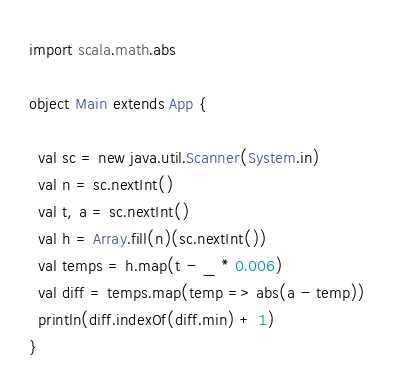<code> <loc_0><loc_0><loc_500><loc_500><_Scala_>import scala.math.abs

object Main extends App {
  
  val sc = new java.util.Scanner(System.in)
  val n = sc.nextInt()
  val t, a = sc.nextInt()
  val h = Array.fill(n)(sc.nextInt())
  val temps = h.map(t - _ * 0.006)
  val diff = temps.map(temp => abs(a - temp))
  println(diff.indexOf(diff.min) + 1)
}</code> 